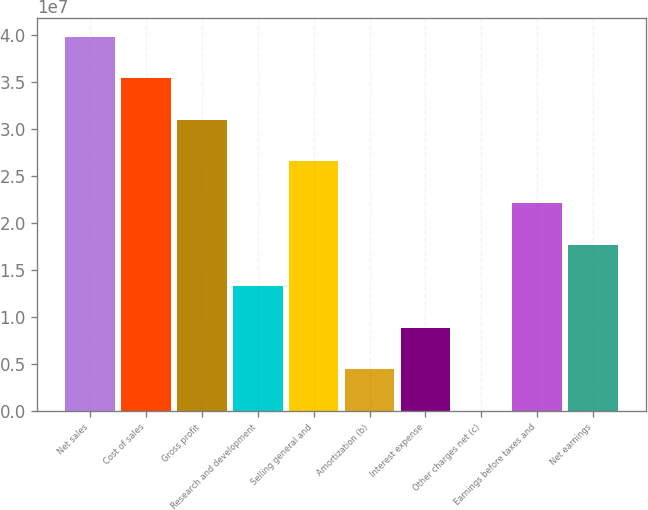Convert chart to OTSL. <chart><loc_0><loc_0><loc_500><loc_500><bar_chart><fcel>Net sales<fcel>Cost of sales<fcel>Gross profit<fcel>Research and development<fcel>Selling general and<fcel>Amortization (b)<fcel>Interest expense<fcel>Other charges net (c)<fcel>Earnings before taxes and<fcel>Net earnings<nl><fcel>3.98135e+07<fcel>3.53898e+07<fcel>3.09661e+07<fcel>1.32712e+07<fcel>2.65423e+07<fcel>4.42376e+06<fcel>8.84748e+06<fcel>42<fcel>2.21186e+07<fcel>1.76949e+07<nl></chart> 